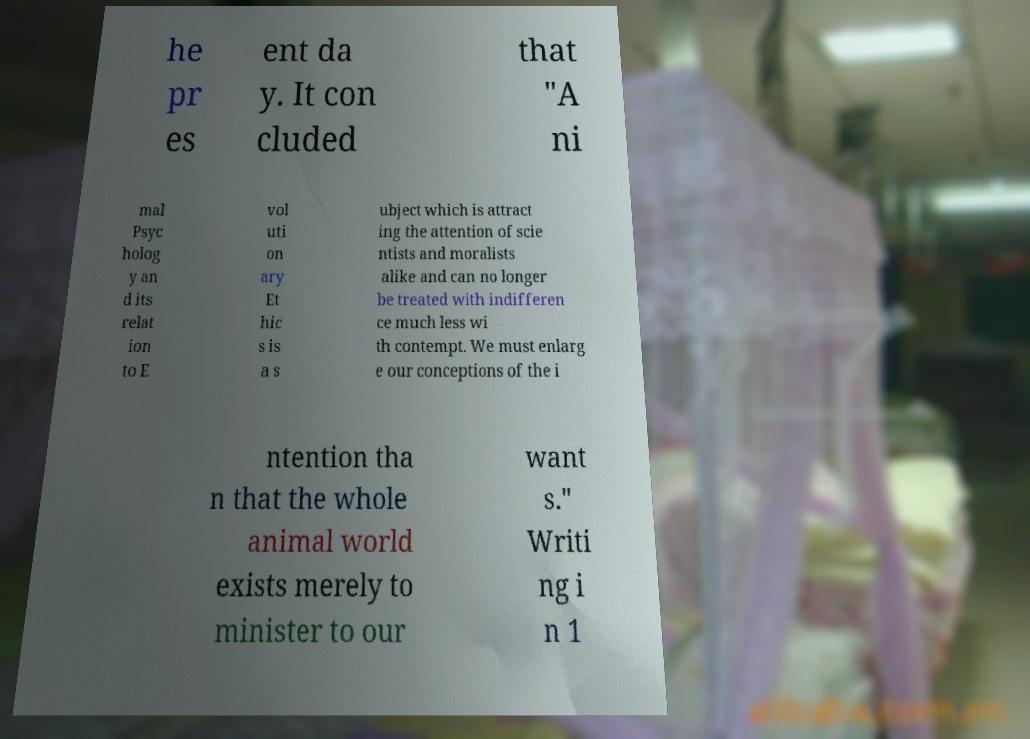Please read and relay the text visible in this image. What does it say? he pr es ent da y. It con cluded that "A ni mal Psyc holog y an d its relat ion to E vol uti on ary Et hic s is a s ubject which is attract ing the attention of scie ntists and moralists alike and can no longer be treated with indifferen ce much less wi th contempt. We must enlarg e our conceptions of the i ntention tha n that the whole animal world exists merely to minister to our want s." Writi ng i n 1 